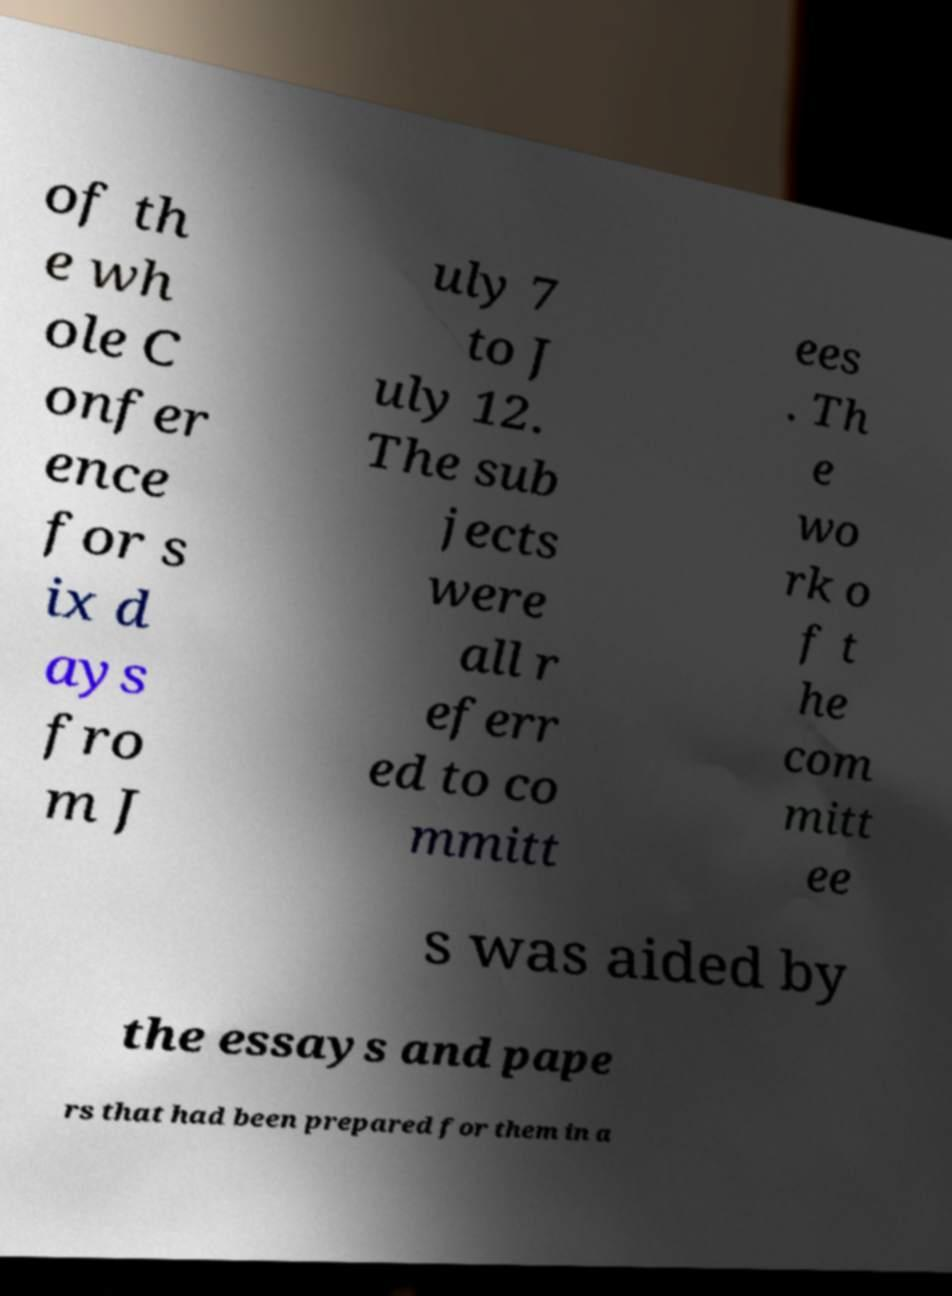Could you extract and type out the text from this image? of th e wh ole C onfer ence for s ix d ays fro m J uly 7 to J uly 12. The sub jects were all r eferr ed to co mmitt ees . Th e wo rk o f t he com mitt ee s was aided by the essays and pape rs that had been prepared for them in a 